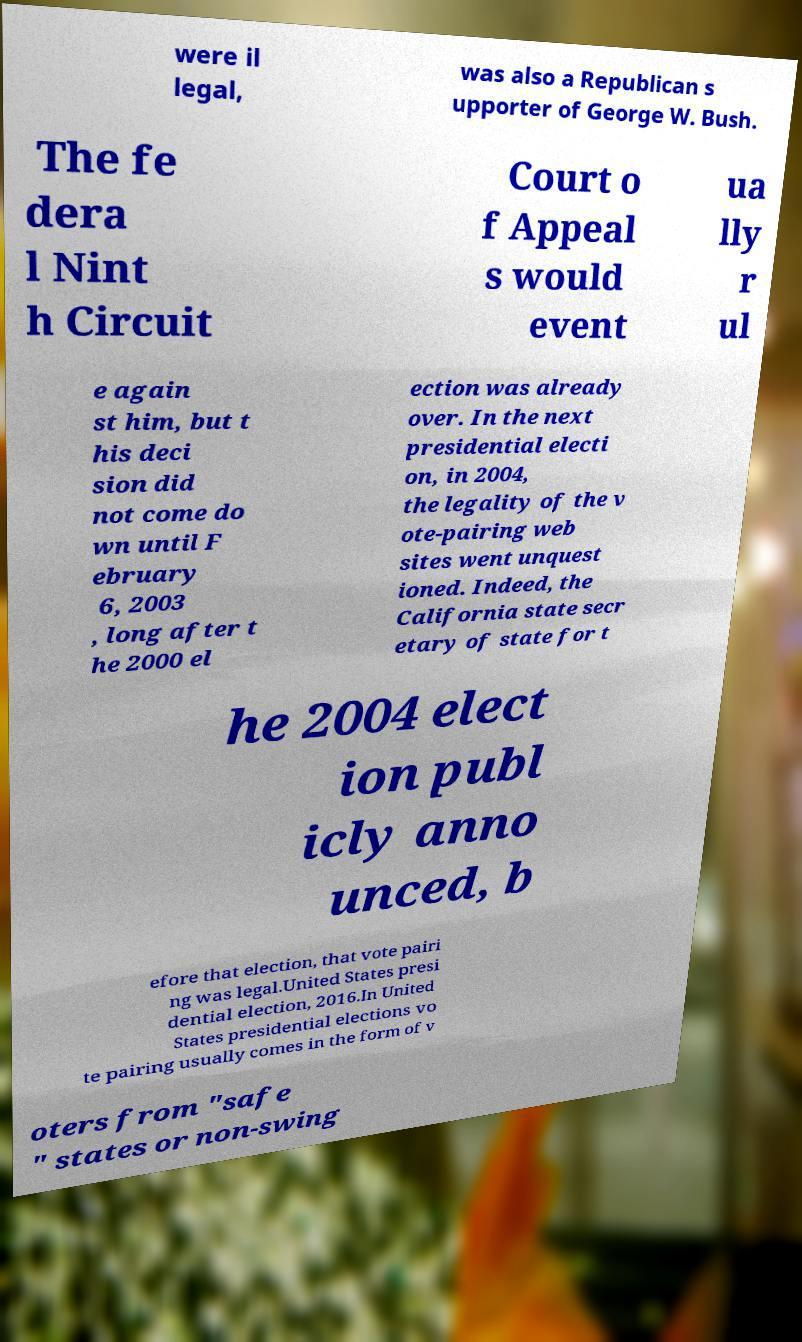Please read and relay the text visible in this image. What does it say? were il legal, was also a Republican s upporter of George W. Bush. The fe dera l Nint h Circuit Court o f Appeal s would event ua lly r ul e again st him, but t his deci sion did not come do wn until F ebruary 6, 2003 , long after t he 2000 el ection was already over. In the next presidential electi on, in 2004, the legality of the v ote-pairing web sites went unquest ioned. Indeed, the California state secr etary of state for t he 2004 elect ion publ icly anno unced, b efore that election, that vote pairi ng was legal.United States presi dential election, 2016.In United States presidential elections vo te pairing usually comes in the form of v oters from "safe " states or non-swing 